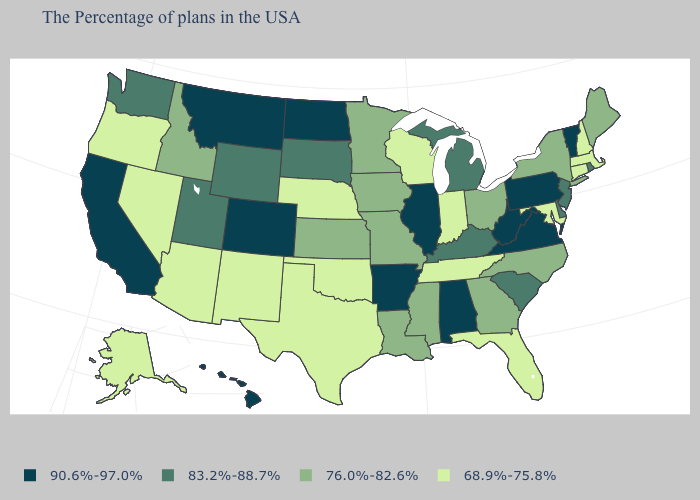Name the states that have a value in the range 68.9%-75.8%?
Give a very brief answer. Massachusetts, New Hampshire, Connecticut, Maryland, Florida, Indiana, Tennessee, Wisconsin, Nebraska, Oklahoma, Texas, New Mexico, Arizona, Nevada, Oregon, Alaska. Name the states that have a value in the range 90.6%-97.0%?
Answer briefly. Vermont, Pennsylvania, Virginia, West Virginia, Alabama, Illinois, Arkansas, North Dakota, Colorado, Montana, California, Hawaii. Name the states that have a value in the range 76.0%-82.6%?
Keep it brief. Maine, New York, North Carolina, Ohio, Georgia, Mississippi, Louisiana, Missouri, Minnesota, Iowa, Kansas, Idaho. What is the value of Idaho?
Give a very brief answer. 76.0%-82.6%. What is the highest value in the USA?
Quick response, please. 90.6%-97.0%. What is the value of Washington?
Give a very brief answer. 83.2%-88.7%. What is the value of Maryland?
Concise answer only. 68.9%-75.8%. Does the map have missing data?
Short answer required. No. What is the value of Rhode Island?
Write a very short answer. 83.2%-88.7%. Does Delaware have the highest value in the USA?
Concise answer only. No. Does the map have missing data?
Keep it brief. No. What is the value of Tennessee?
Concise answer only. 68.9%-75.8%. What is the highest value in the South ?
Quick response, please. 90.6%-97.0%. What is the value of Tennessee?
Keep it brief. 68.9%-75.8%. 